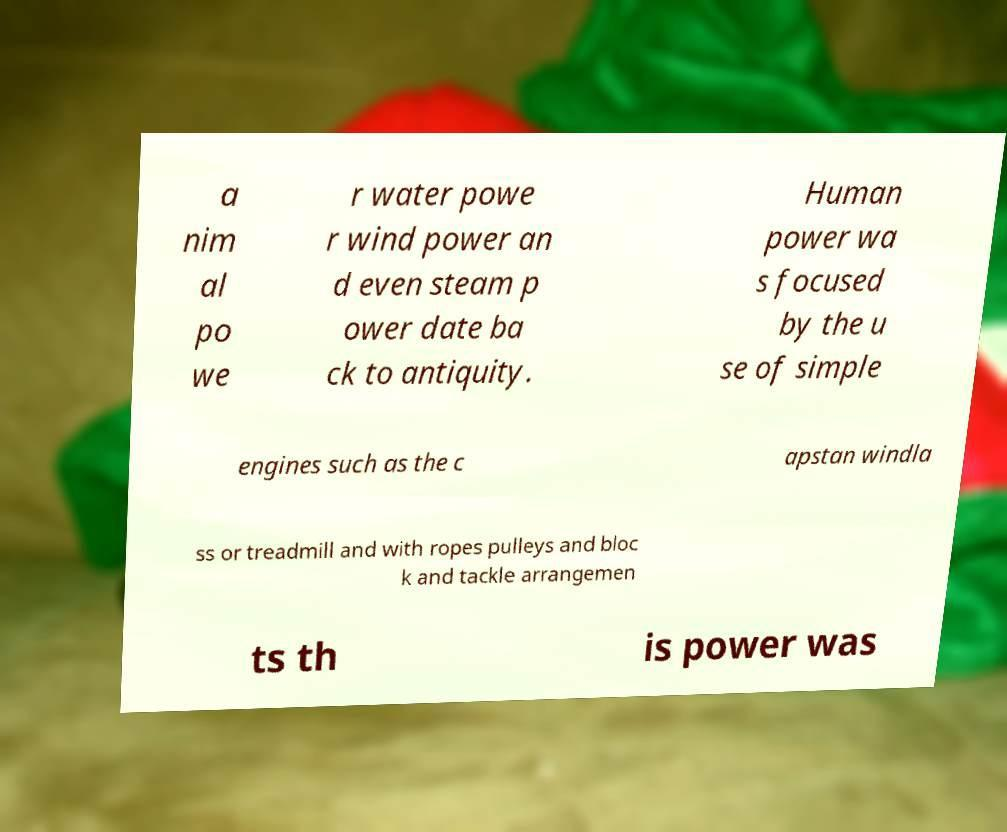Could you assist in decoding the text presented in this image and type it out clearly? a nim al po we r water powe r wind power an d even steam p ower date ba ck to antiquity. Human power wa s focused by the u se of simple engines such as the c apstan windla ss or treadmill and with ropes pulleys and bloc k and tackle arrangemen ts th is power was 